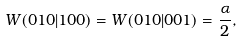Convert formula to latex. <formula><loc_0><loc_0><loc_500><loc_500>W ( 0 1 0 | 1 0 0 ) = W ( 0 1 0 | 0 0 1 ) = \frac { \alpha } { 2 } ,</formula> 